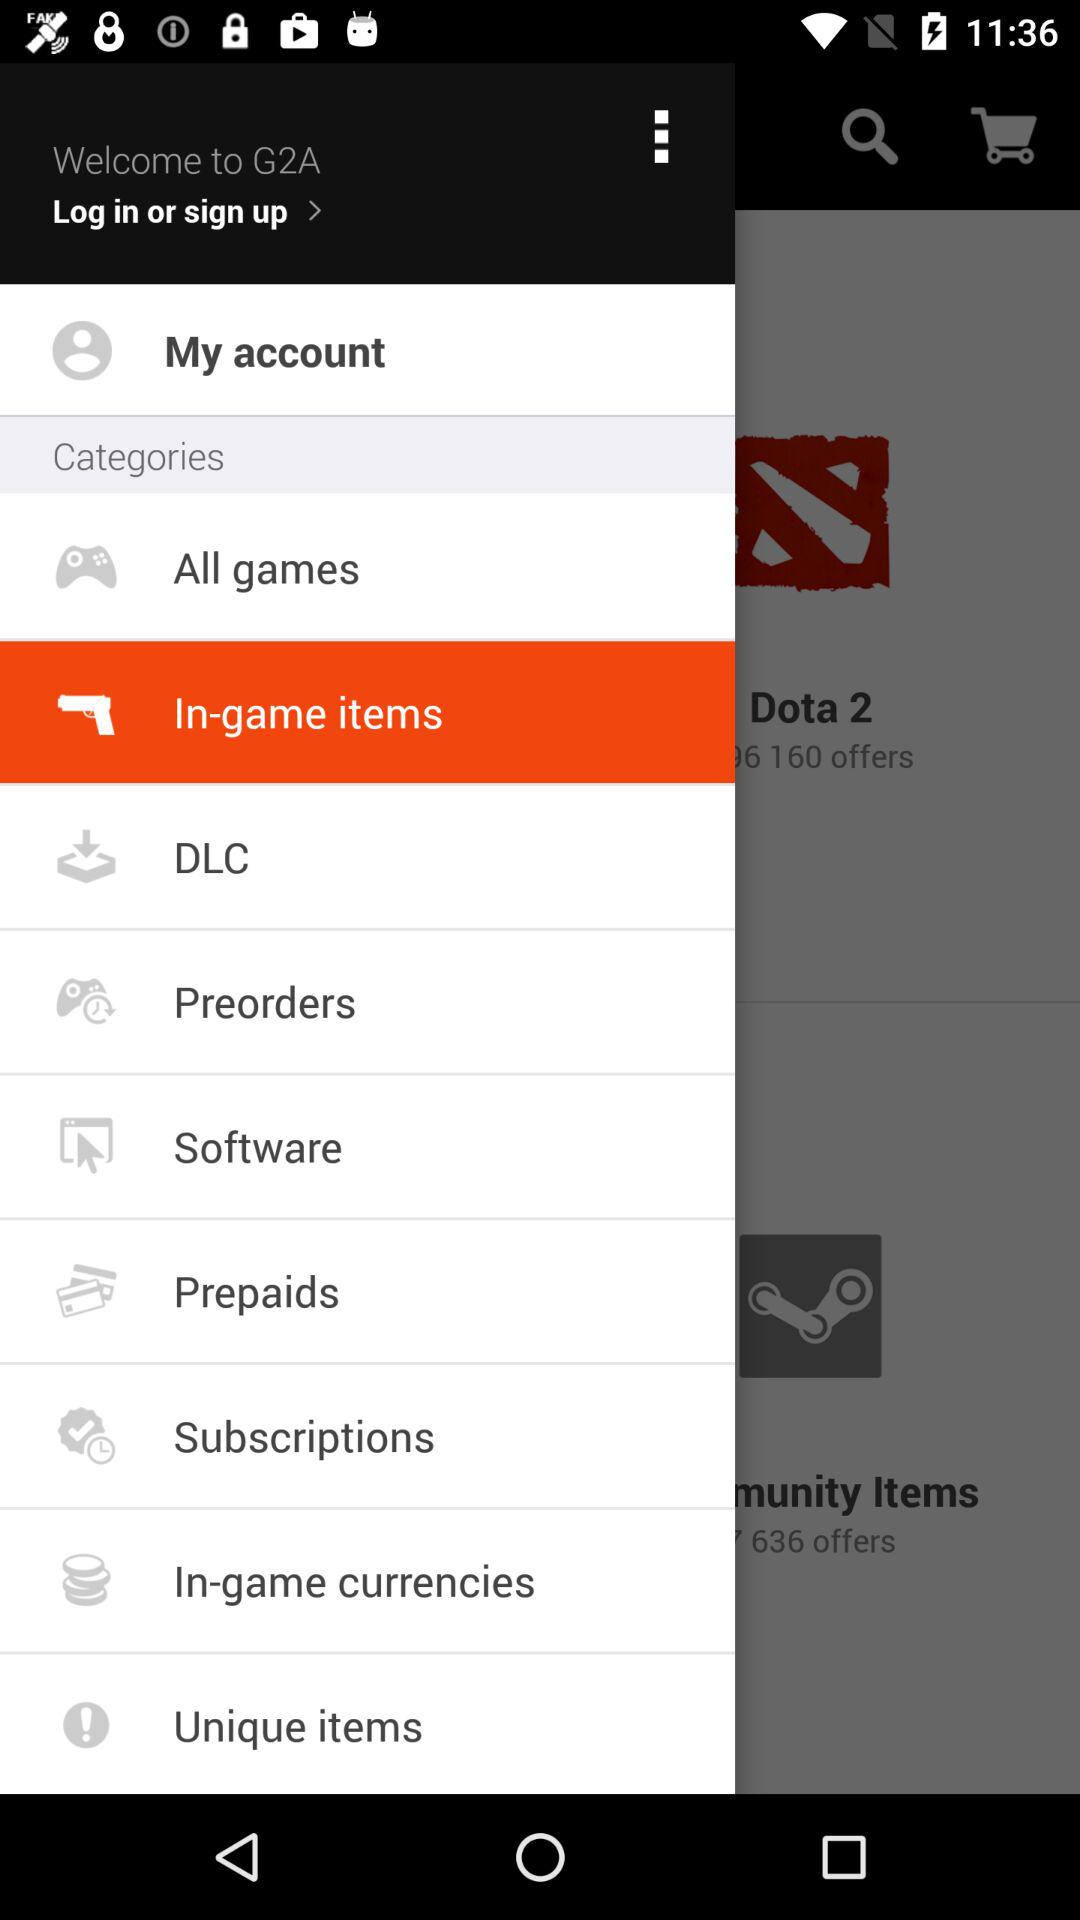What is the user name? The user name is G2A. 